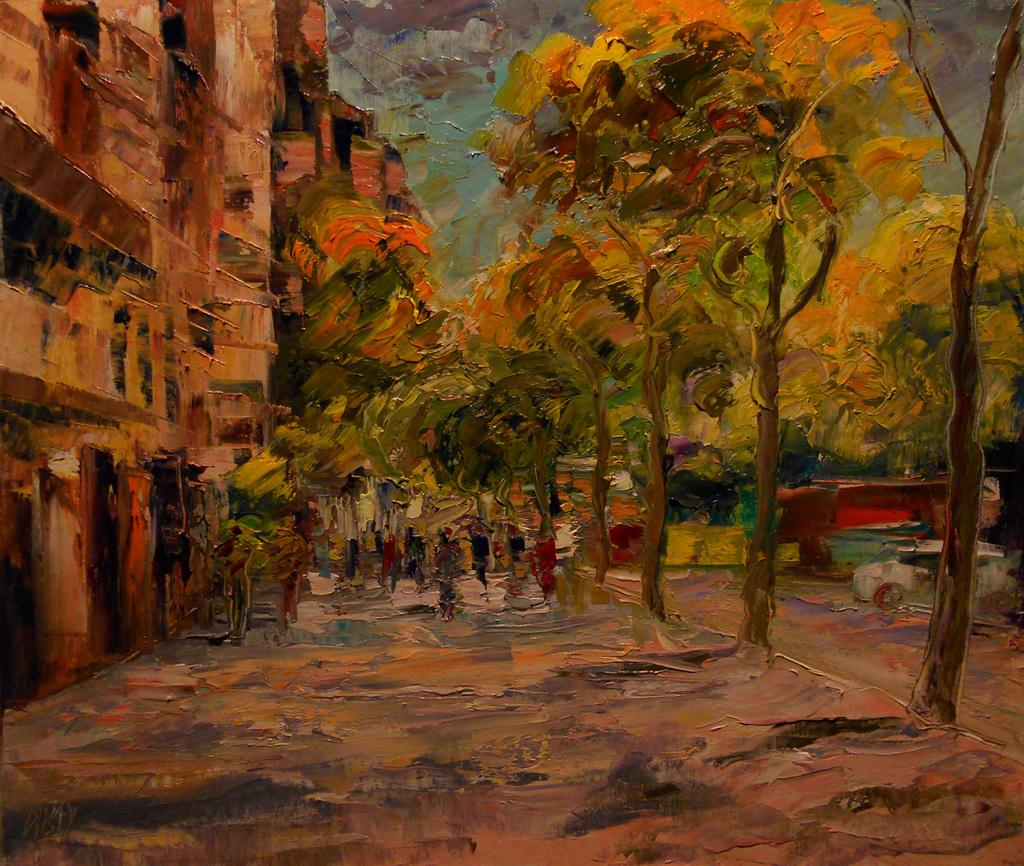What type of artwork is depicted in the image? The image is a painting. What natural elements can be seen in the painting? There are trees in the image. What man-made structures are present in the painting? There are buildings in the image. Are there any human figures in the painting? Yes, there are people in the image. What mode of transportation is visible in the painting? There is a vehicle in the image. What can be seen in the background of the painting? The sky is visible in the background of the image. What type of cabbage is being used as a weapon in the attack depicted in the painting? There is no attack or cabbage present in the painting; it features trees, buildings, people, a vehicle, and the sky. 